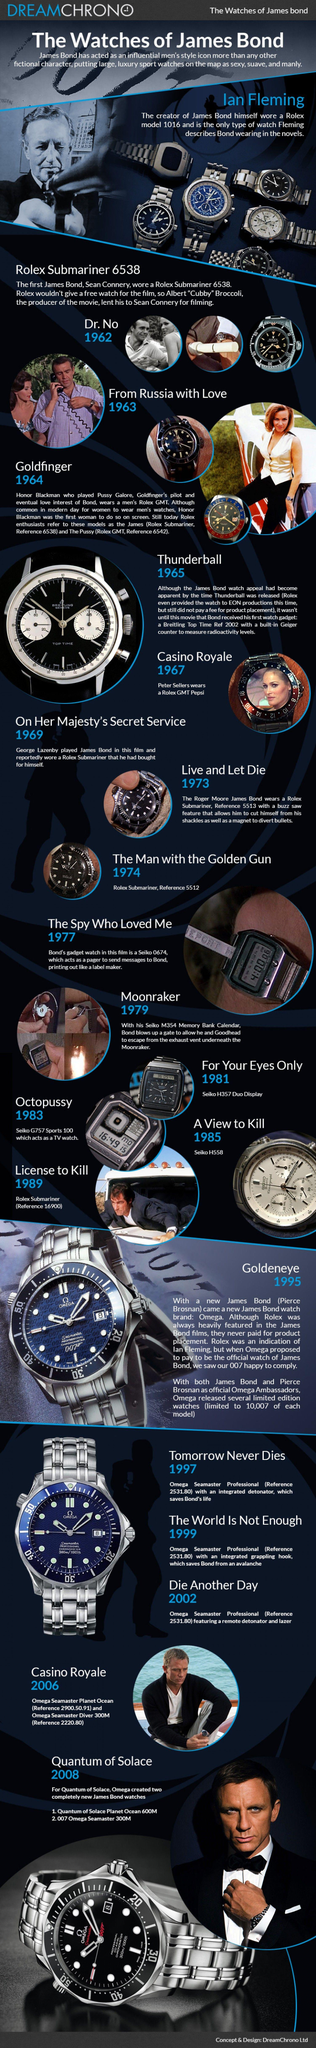Point out several critical features in this image. Honor Blackman wore a Rolex on screen. Ian Fleming wore a Rolex model 1016 watch. 